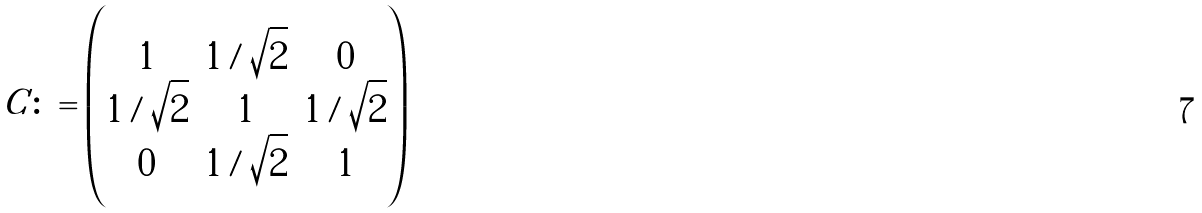Convert formula to latex. <formula><loc_0><loc_0><loc_500><loc_500>C \colon = \begin{pmatrix} 1 & 1 / \sqrt { 2 } & 0 \\ 1 / \sqrt { 2 } & 1 & 1 / \sqrt { 2 } \\ 0 & 1 / \sqrt { 2 } & 1 \end{pmatrix}</formula> 